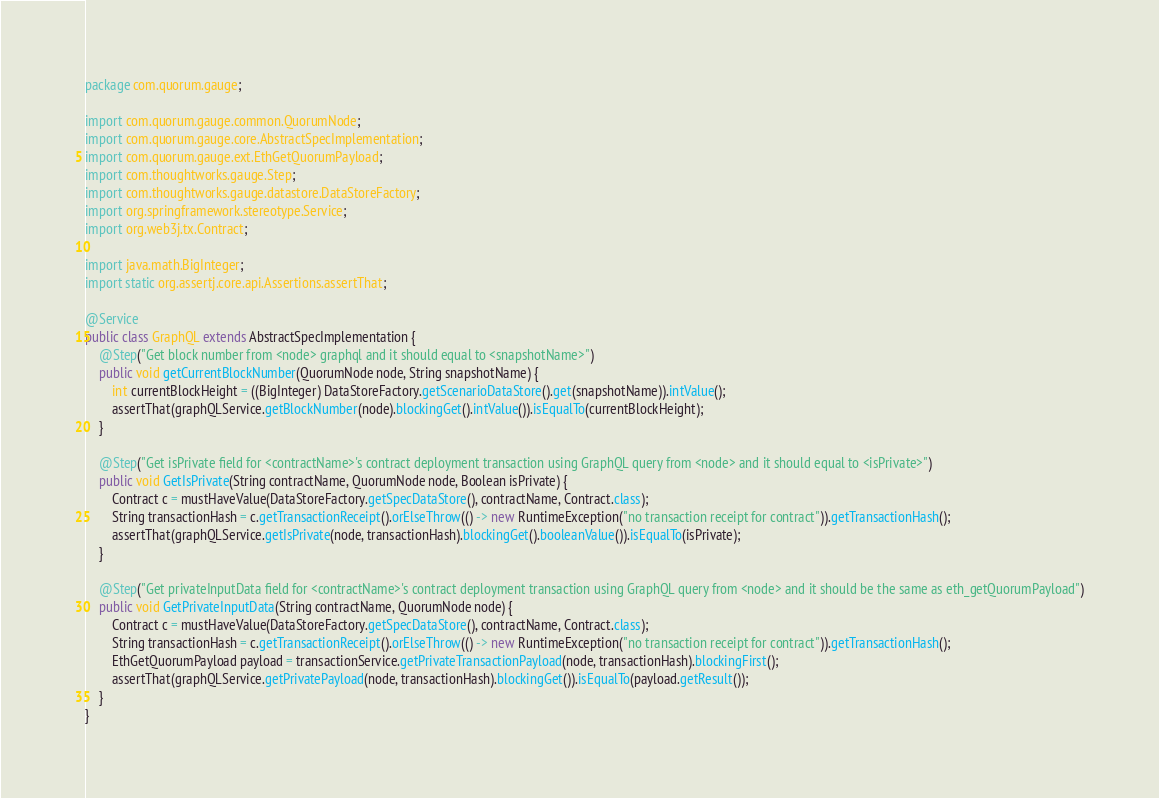Convert code to text. <code><loc_0><loc_0><loc_500><loc_500><_Java_>package com.quorum.gauge;

import com.quorum.gauge.common.QuorumNode;
import com.quorum.gauge.core.AbstractSpecImplementation;
import com.quorum.gauge.ext.EthGetQuorumPayload;
import com.thoughtworks.gauge.Step;
import com.thoughtworks.gauge.datastore.DataStoreFactory;
import org.springframework.stereotype.Service;
import org.web3j.tx.Contract;

import java.math.BigInteger;
import static org.assertj.core.api.Assertions.assertThat;

@Service
public class GraphQL extends AbstractSpecImplementation {
    @Step("Get block number from <node> graphql and it should equal to <snapshotName>")
    public void getCurrentBlockNumber(QuorumNode node, String snapshotName) {
        int currentBlockHeight = ((BigInteger) DataStoreFactory.getScenarioDataStore().get(snapshotName)).intValue();
        assertThat(graphQLService.getBlockNumber(node).blockingGet().intValue()).isEqualTo(currentBlockHeight);
    }

    @Step("Get isPrivate field for <contractName>'s contract deployment transaction using GraphQL query from <node> and it should equal to <isPrivate>")
    public void GetIsPrivate(String contractName, QuorumNode node, Boolean isPrivate) {
        Contract c = mustHaveValue(DataStoreFactory.getSpecDataStore(), contractName, Contract.class);
        String transactionHash = c.getTransactionReceipt().orElseThrow(() -> new RuntimeException("no transaction receipt for contract")).getTransactionHash();
        assertThat(graphQLService.getIsPrivate(node, transactionHash).blockingGet().booleanValue()).isEqualTo(isPrivate);
    }

    @Step("Get privateInputData field for <contractName>'s contract deployment transaction using GraphQL query from <node> and it should be the same as eth_getQuorumPayload")
    public void GetPrivateInputData(String contractName, QuorumNode node) {
        Contract c = mustHaveValue(DataStoreFactory.getSpecDataStore(), contractName, Contract.class);
        String transactionHash = c.getTransactionReceipt().orElseThrow(() -> new RuntimeException("no transaction receipt for contract")).getTransactionHash();
        EthGetQuorumPayload payload = transactionService.getPrivateTransactionPayload(node, transactionHash).blockingFirst();
        assertThat(graphQLService.getPrivatePayload(node, transactionHash).blockingGet()).isEqualTo(payload.getResult());
    }
}
</code> 